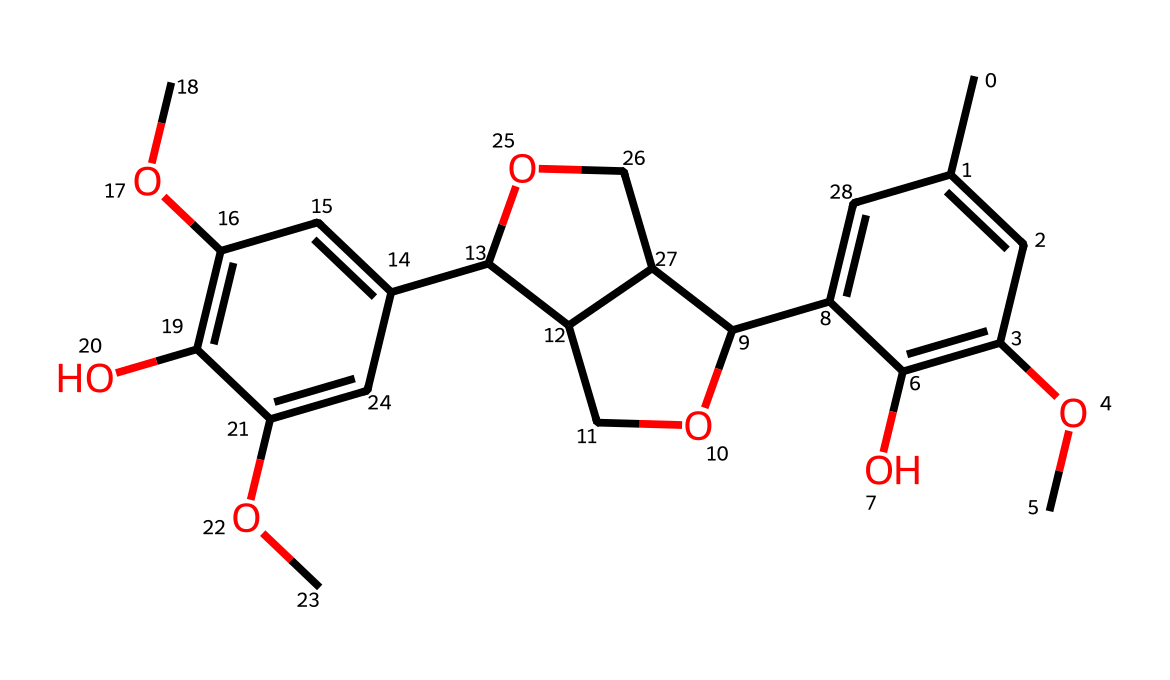What is the total number of carbon atoms in this chemical? By analyzing the SMILES representation, we can count the carbon atoms. The “C” indicates carbon, and we account for the lone carbon atoms as well as those in cyclic structures. After careful counting, there are 21 carbon atoms.
Answer: 21 How many oxygen atoms are present in this structure? In the SMILES notation, “O” represents oxygen atoms. We can count the instances of “O” in the representation. There are 6 instances of oxygen.
Answer: 6 What type of bonding is predominantly seen in the aromatic ring? The aromatic structure typically consists of alternating single and double bonds. In the SMILES, the double bonds can be inferred by the presence of "=" next to carbon atoms. The presence of these bonds signifies resonance characteristic of aromatic compounds.
Answer: resonance Does this chemical contain any hydroxyl groups? A hydroxyl group is represented by “-OH” in organic molecules. By examining the SMILES, we look for “O” connected to “C” without any double bond. We do find instances indicating hydroxyl groups, specifically where the oxygen is bonded in a single manner.
Answer: yes What functional groups are identified in this aromatic compound? By analyzing the structure from the SMILES, we can identify functional groups such as methoxy groups “-OCH3” and hydroxyl groups “-OH”. These groups modify the compound's chemical properties significantly.
Answer: methoxy and hydroxyl 